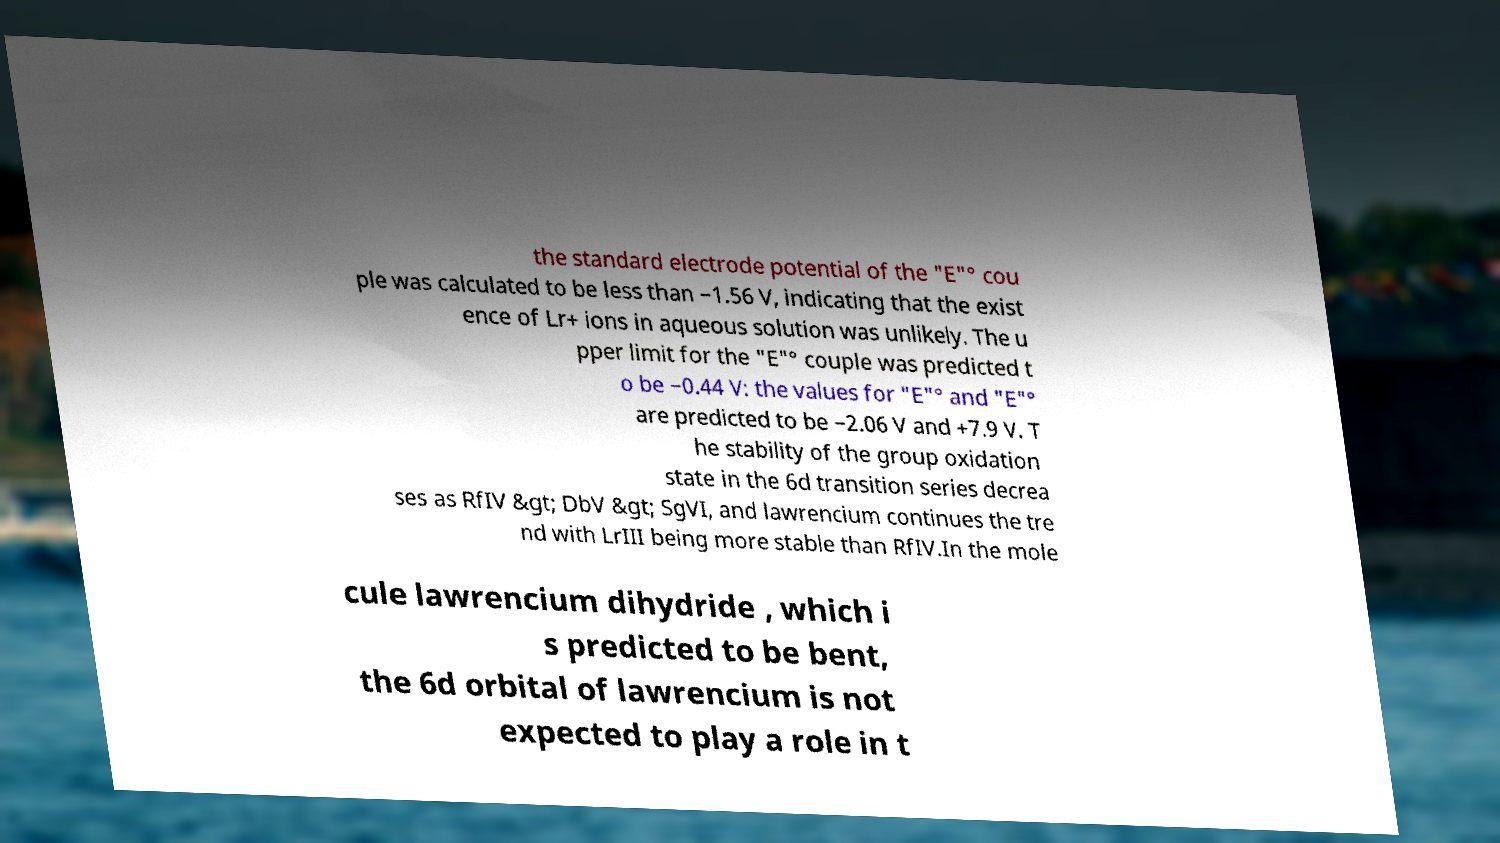Can you accurately transcribe the text from the provided image for me? the standard electrode potential of the "E"° cou ple was calculated to be less than −1.56 V, indicating that the exist ence of Lr+ ions in aqueous solution was unlikely. The u pper limit for the "E"° couple was predicted t o be −0.44 V: the values for "E"° and "E"° are predicted to be −2.06 V and +7.9 V. T he stability of the group oxidation state in the 6d transition series decrea ses as RfIV &gt; DbV &gt; SgVI, and lawrencium continues the tre nd with LrIII being more stable than RfIV.In the mole cule lawrencium dihydride , which i s predicted to be bent, the 6d orbital of lawrencium is not expected to play a role in t 